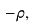Convert formula to latex. <formula><loc_0><loc_0><loc_500><loc_500>- \rho ,</formula> 